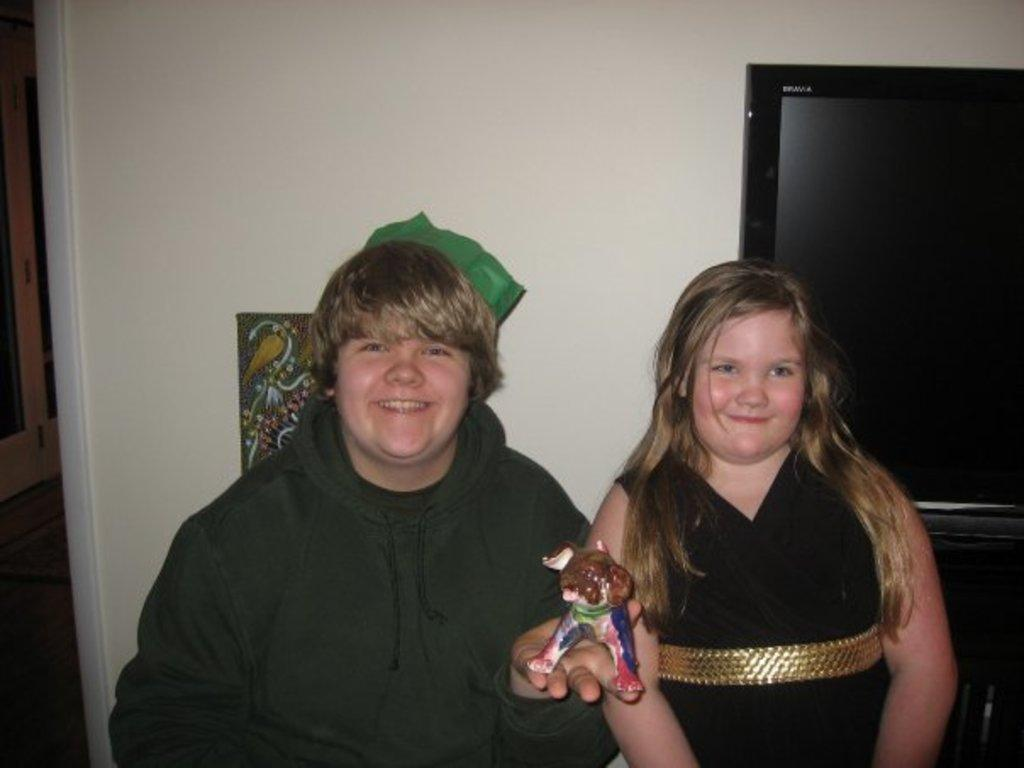How many people are in the image? There are two people in the image, a boy and a girl. What are the positions of the boy and the girl in the image? The boy is standing, and the girl is standing. What is the boy holding in the image? The boy is holding a toy. What can be seen in the background of the image? There is a television in the background of the image. What is the color of the wall in the image? The wall in the image is white. What type of industry is depicted in the image? There is no industry depicted in the image; it features a boy, a girl, and a toy. What is the boy measuring in the image? The boy is not measuring anything in the image; he is holding a toy. 